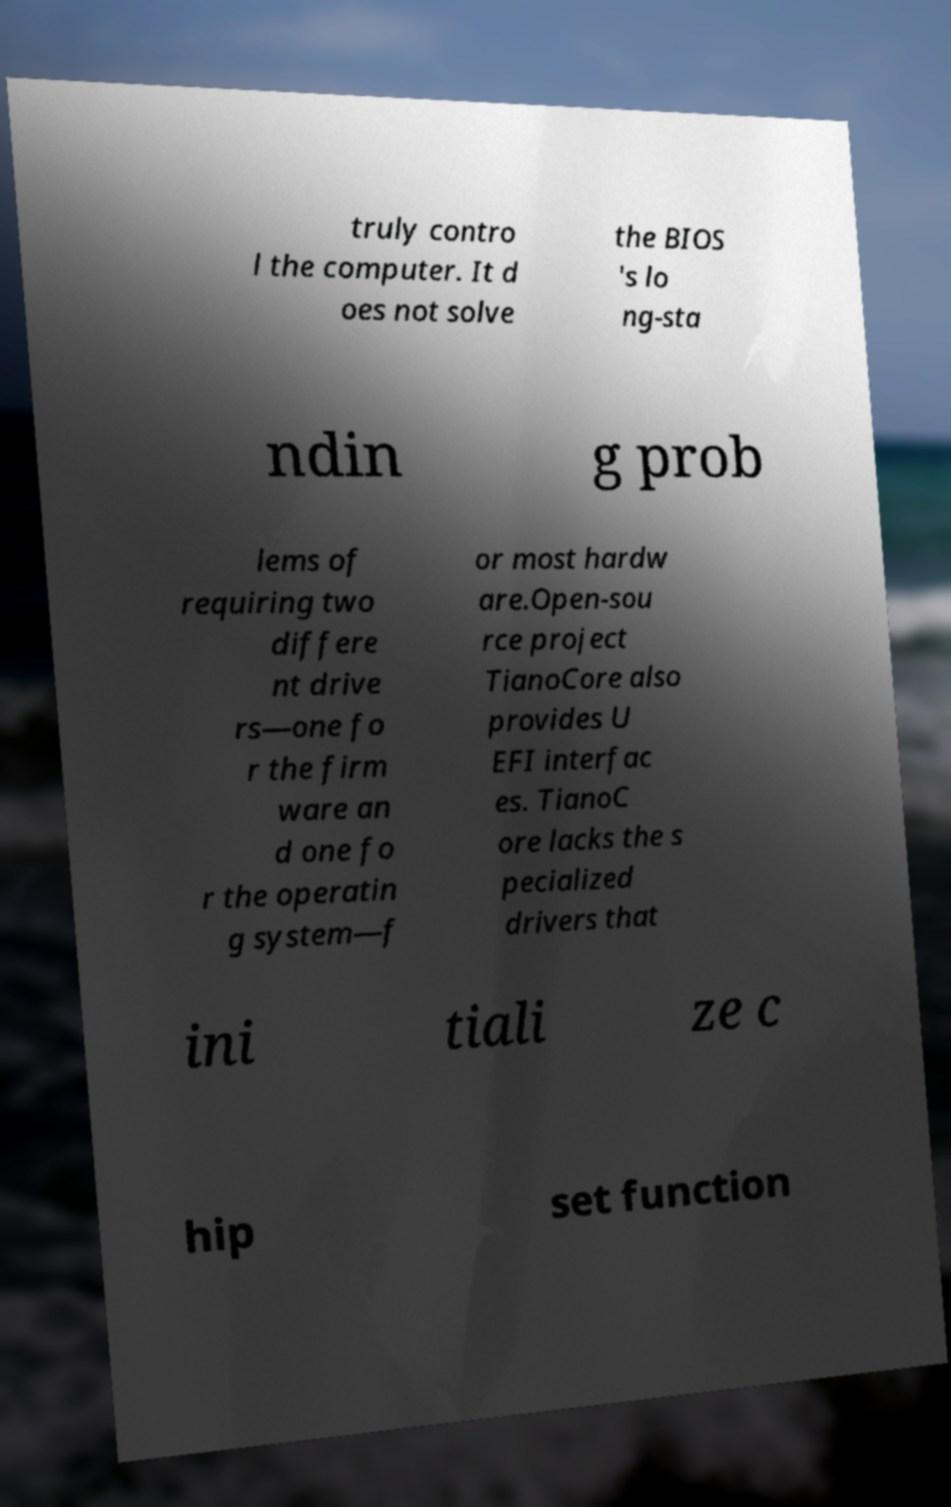Please read and relay the text visible in this image. What does it say? truly contro l the computer. It d oes not solve the BIOS 's lo ng-sta ndin g prob lems of requiring two differe nt drive rs—one fo r the firm ware an d one fo r the operatin g system—f or most hardw are.Open-sou rce project TianoCore also provides U EFI interfac es. TianoC ore lacks the s pecialized drivers that ini tiali ze c hip set function 